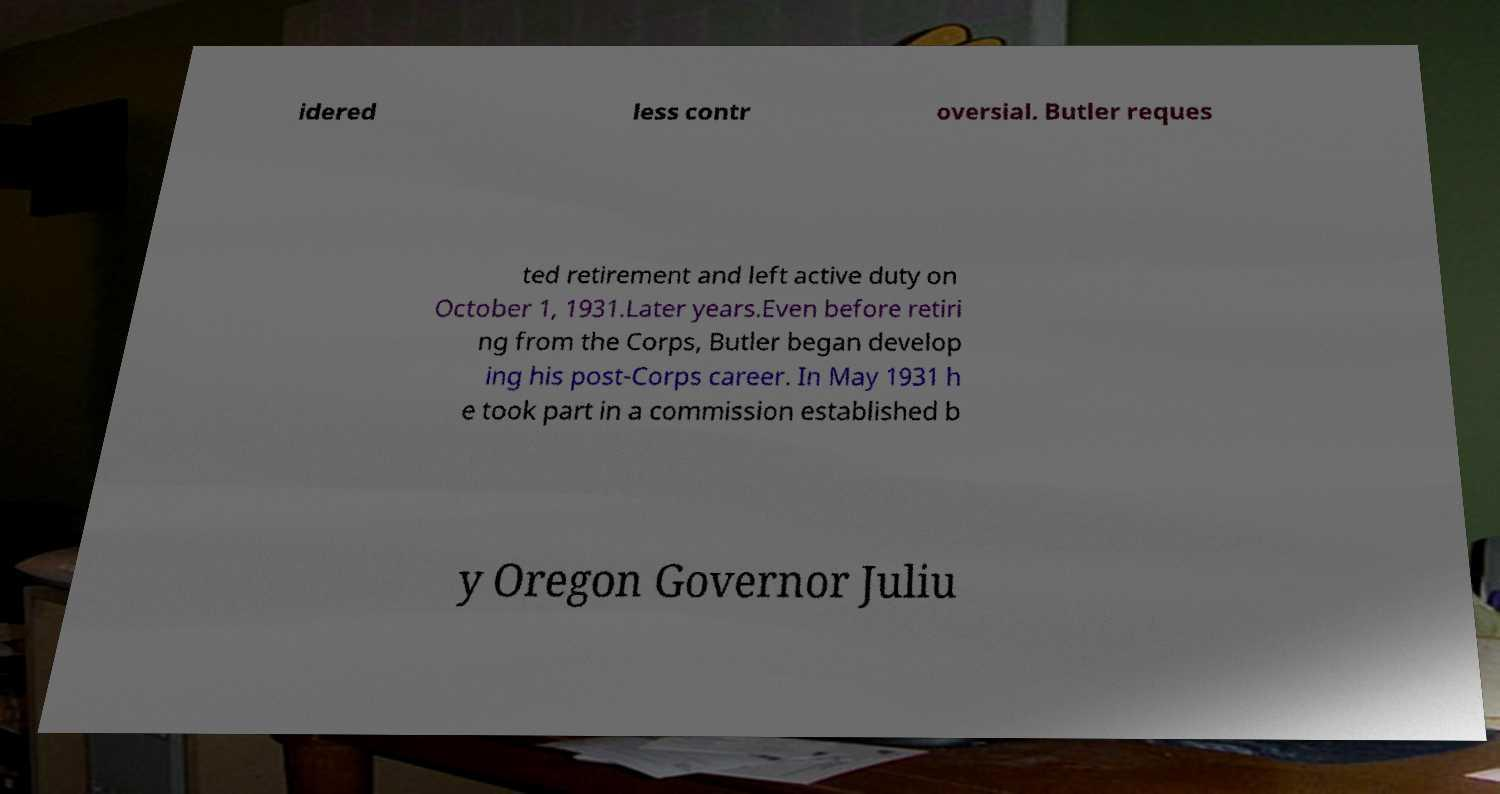Could you assist in decoding the text presented in this image and type it out clearly? idered less contr oversial. Butler reques ted retirement and left active duty on October 1, 1931.Later years.Even before retiri ng from the Corps, Butler began develop ing his post-Corps career. In May 1931 h e took part in a commission established b y Oregon Governor Juliu 